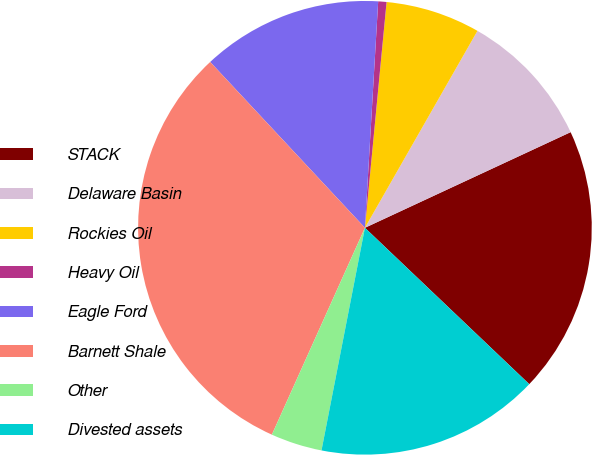Convert chart to OTSL. <chart><loc_0><loc_0><loc_500><loc_500><pie_chart><fcel>STACK<fcel>Delaware Basin<fcel>Rockies Oil<fcel>Heavy Oil<fcel>Eagle Ford<fcel>Barnett Shale<fcel>Other<fcel>Divested assets<nl><fcel>19.03%<fcel>9.81%<fcel>6.74%<fcel>0.59%<fcel>12.88%<fcel>31.32%<fcel>3.66%<fcel>15.96%<nl></chart> 